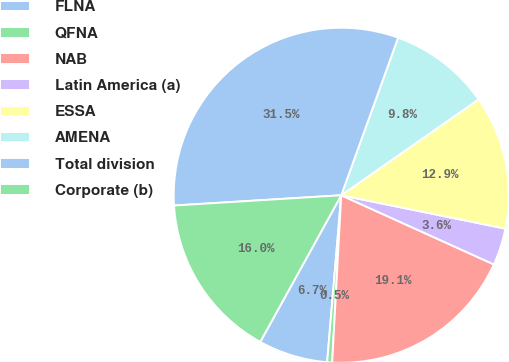Convert chart. <chart><loc_0><loc_0><loc_500><loc_500><pie_chart><fcel>FLNA<fcel>QFNA<fcel>NAB<fcel>Latin America (a)<fcel>ESSA<fcel>AMENA<fcel>Total division<fcel>Corporate (b)<nl><fcel>6.69%<fcel>0.48%<fcel>19.09%<fcel>3.58%<fcel>12.89%<fcel>9.79%<fcel>31.49%<fcel>15.99%<nl></chart> 